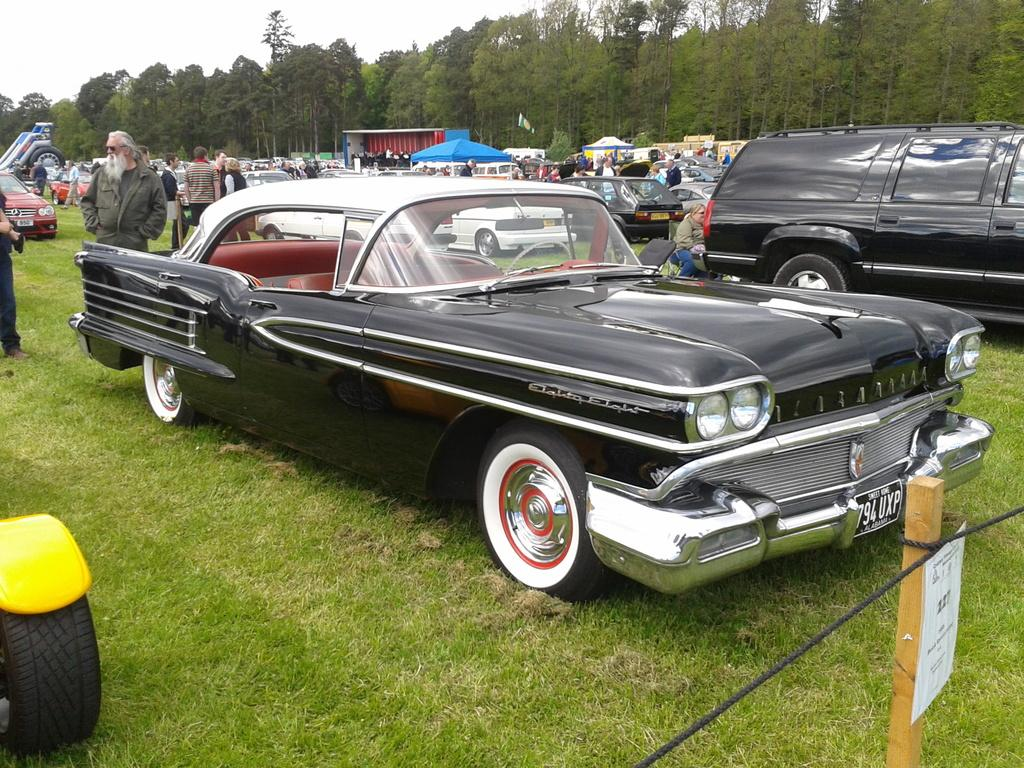What is the unusual location for the parked cars in the image? The cars are parked on the grass in the image. What else can be seen in the image besides the parked cars? There are people standing in the image, as well as stalls and trees in the background. What is the condition of the sky in the image? The sky is visible in the background of the image. What is the price of the loaf of bread at the stall in the image? There is no loaf of bread or price mentioned in the image; it only shows parked cars, people, stalls, trees, and the sky. 